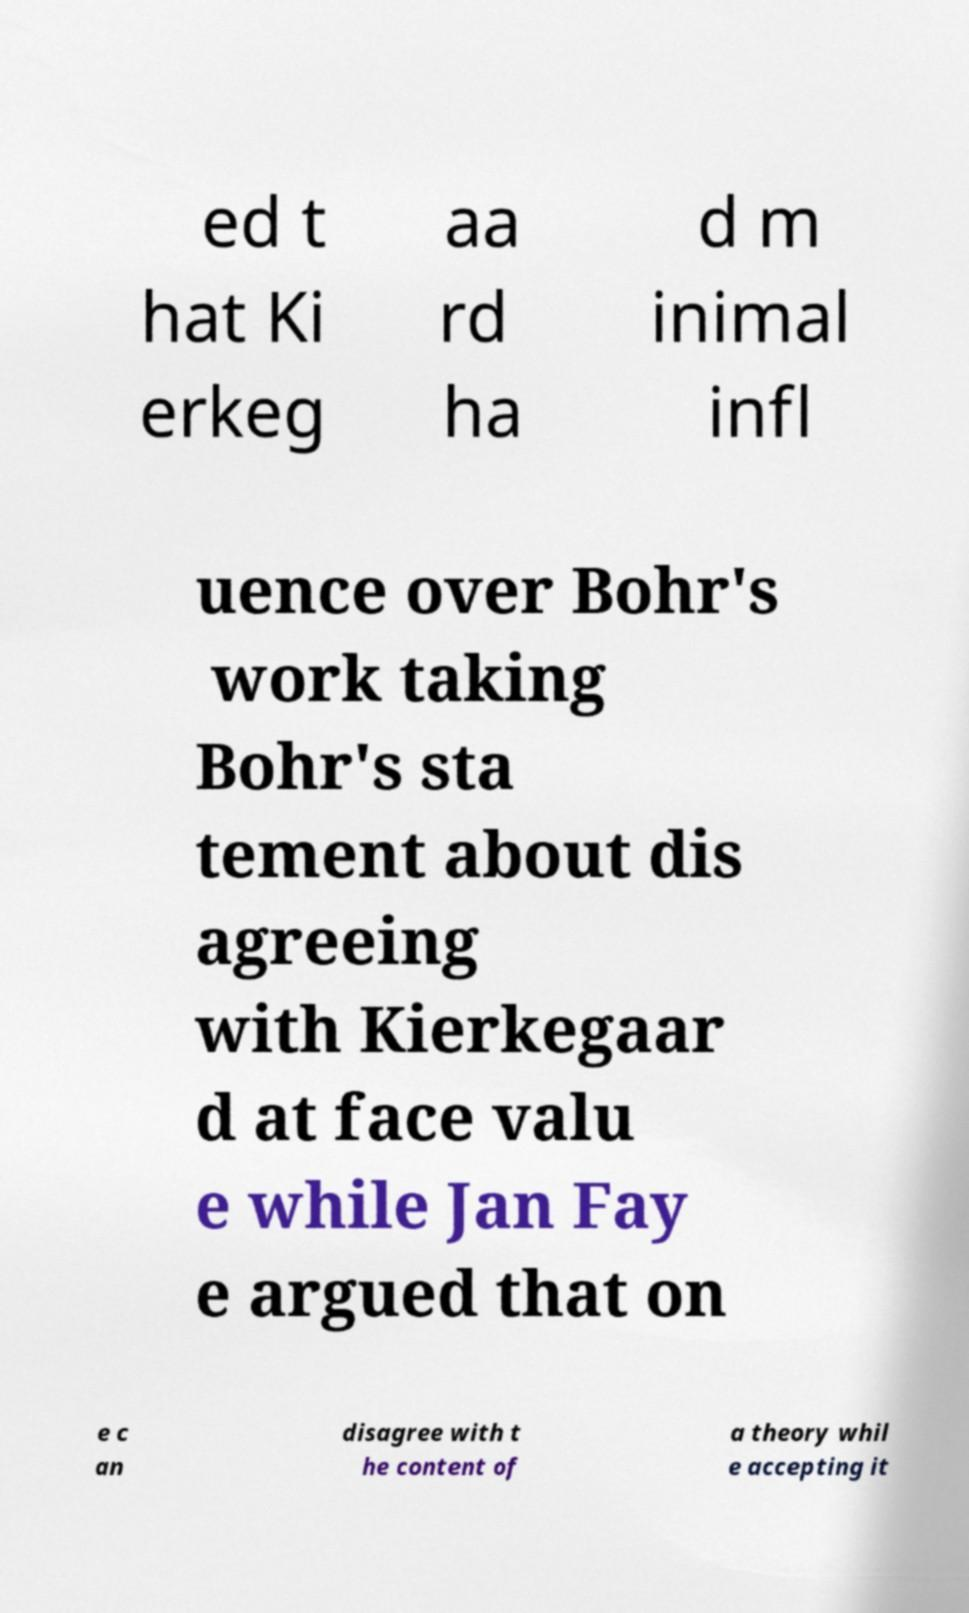I need the written content from this picture converted into text. Can you do that? ed t hat Ki erkeg aa rd ha d m inimal infl uence over Bohr's work taking Bohr's sta tement about dis agreeing with Kierkegaar d at face valu e while Jan Fay e argued that on e c an disagree with t he content of a theory whil e accepting it 